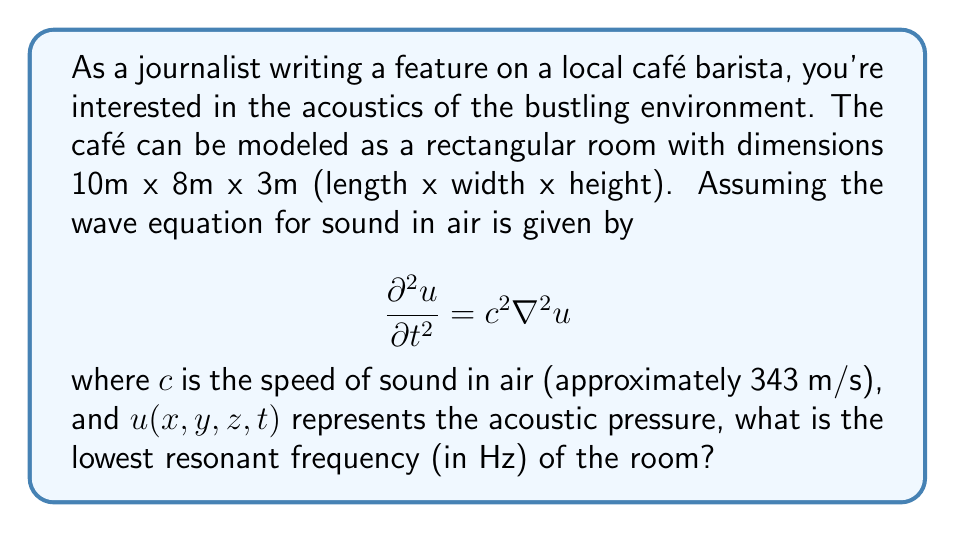Show me your answer to this math problem. To solve this problem, we need to consider the resonant frequencies of a rectangular room. These frequencies are determined by the room's dimensions and the speed of sound.

1) The general formula for resonant frequencies in a rectangular room is:

   $$ f_{nml} = \frac{c}{2} \sqrt{\left(\frac{n}{L_x}\right)^2 + \left(\frac{m}{L_y}\right)^2 + \left(\frac{l}{L_z}\right)^2} $$

   where $n$, $m$, and $l$ are non-negative integers, and $L_x$, $L_y$, and $L_z$ are the room dimensions.

2) The lowest resonant frequency occurs when $n = 1$, $m = 0$, and $l = 0$, corresponding to the longest dimension of the room.

3) In this case, $L_x = 10$ m (the longest dimension), so we have:

   $$ f_{100} = \frac{c}{2L_x} $$

4) Substituting the values:

   $$ f_{100} = \frac{343 \text{ m/s}}{2 \cdot 10 \text{ m}} = 17.15 \text{ Hz} $$

5) Round to two decimal places for the final answer.

This lowest resonant frequency corresponds to a standing wave that fits exactly half a wavelength along the room's length.
Answer: 17.15 Hz 